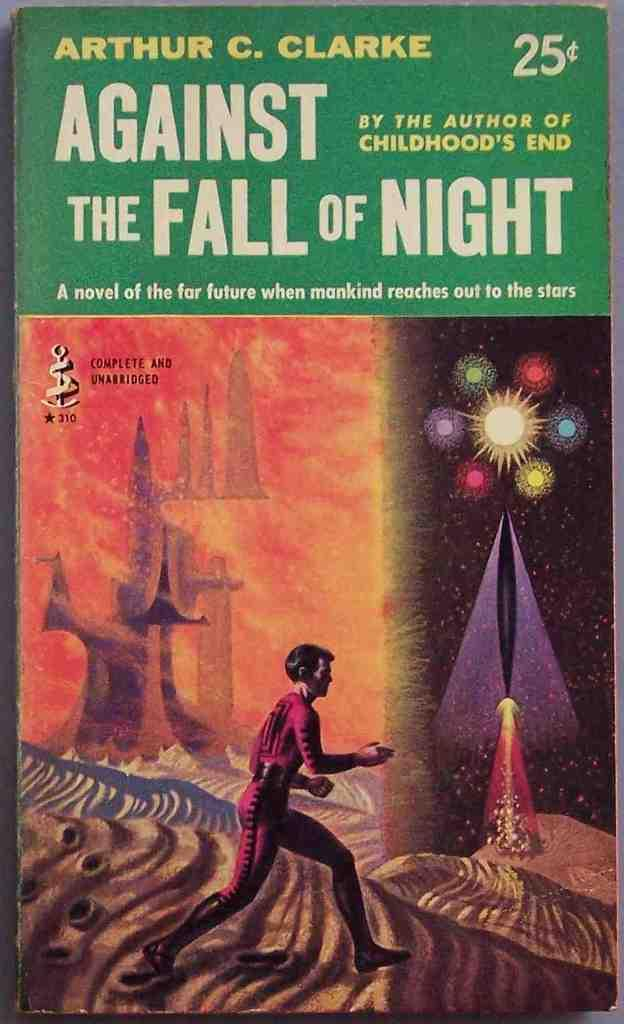What is the main subject of the image? The main subject of the image is the cover page of a book. What can be found on the cover page? The cover page contains images and text. What type of dog can be seen playing with a spring on the cover page? There is no dog or spring present on the cover page; it only contains images and text related to the book. 